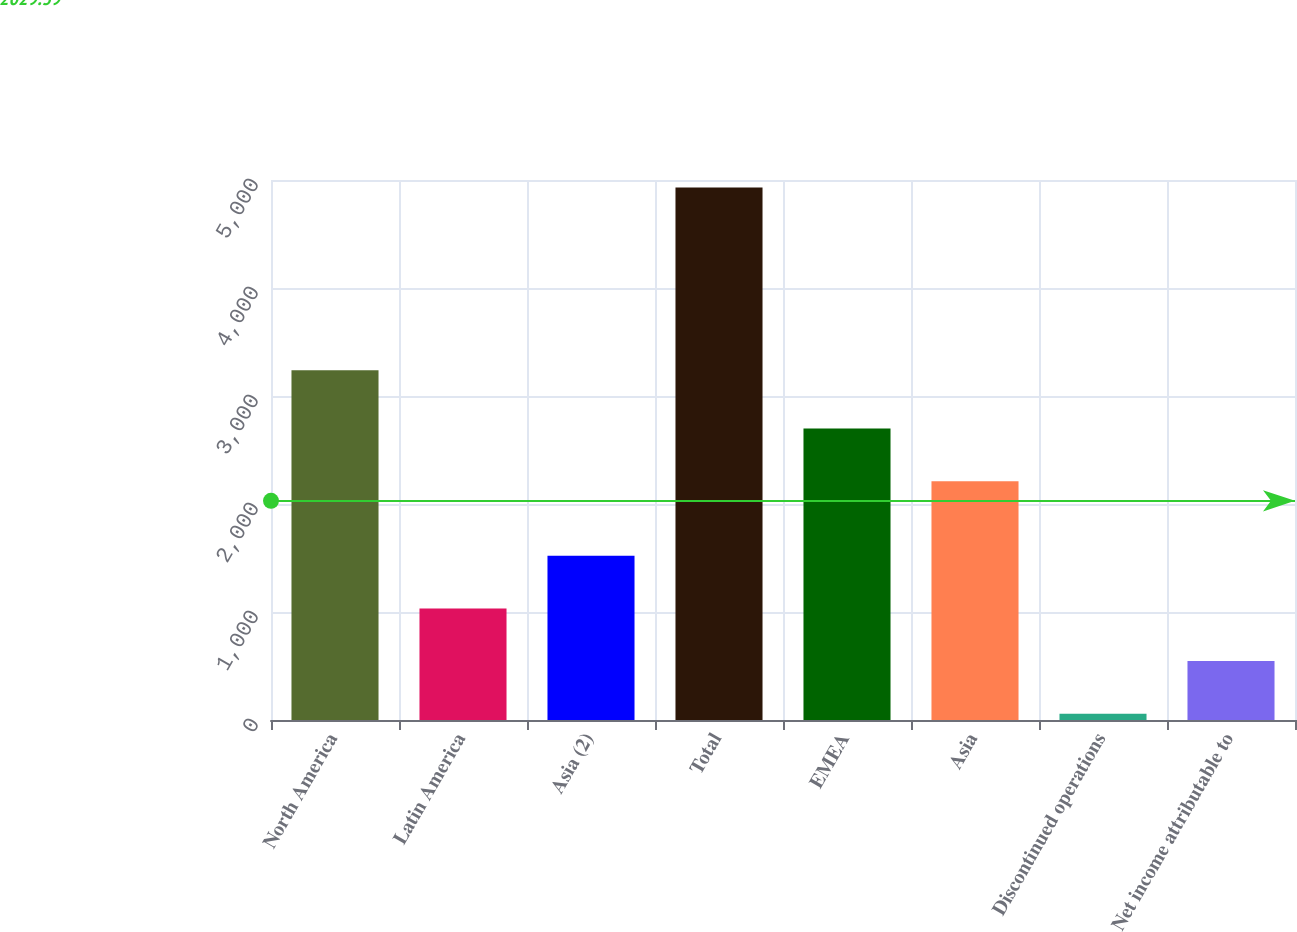Convert chart to OTSL. <chart><loc_0><loc_0><loc_500><loc_500><bar_chart><fcel>North America<fcel>Latin America<fcel>Asia (2)<fcel>Total<fcel>EMEA<fcel>Asia<fcel>Discontinued operations<fcel>Net income attributable to<nl><fcel>3239<fcel>1032.6<fcel>1519.9<fcel>4931<fcel>2698.3<fcel>2211<fcel>58<fcel>545.3<nl></chart> 